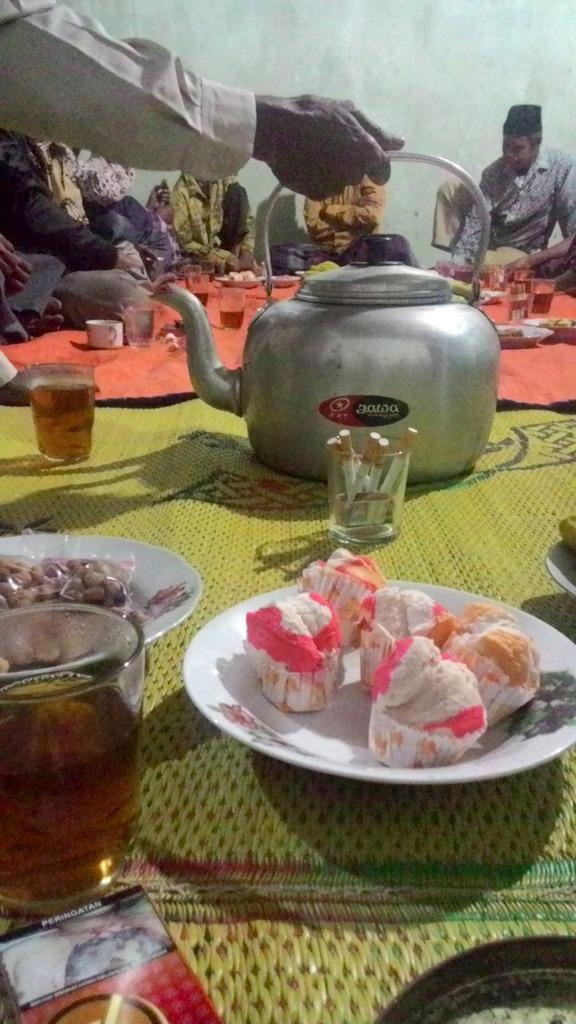Who or what is present in the image? There are people in the image. What is the main object in the image? There is a table in the image. What items are on the table? There are plates, glasses, and food items on the table. Where is the drain located in the image? There is no drain present in the image. What type of sticks are being used by the people in the image? There is no mention of sticks in the image; the people are likely using utensils like forks or spoons to eat the food items on the table. 